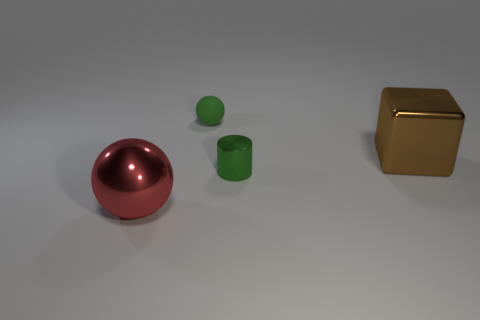Is there anything else that has the same material as the green sphere?
Make the answer very short. No. How many things are either brown rubber cylinders or things that are to the right of the big red thing?
Your response must be concise. 3. Are there any green cylinders made of the same material as the large cube?
Give a very brief answer. Yes. What number of things are both in front of the large brown cube and to the right of the small green shiny cylinder?
Make the answer very short. 0. What is the material of the object behind the big brown object?
Your answer should be compact. Rubber. There is a red thing that is the same material as the tiny green cylinder; what size is it?
Offer a terse response. Large. There is a small rubber sphere; are there any small green objects in front of it?
Provide a short and direct response. Yes. What size is the red metal object that is the same shape as the green rubber thing?
Your response must be concise. Large. Do the tiny matte ball and the big thing left of the tiny green cylinder have the same color?
Ensure brevity in your answer.  No. Does the cylinder have the same color as the big cube?
Provide a succinct answer. No. 